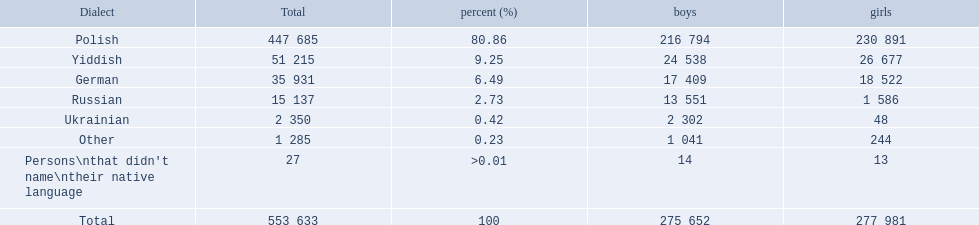What were the languages in plock governorate? Polish, Yiddish, German, Russian, Ukrainian, Other. Which language has a value of .42? Ukrainian. 